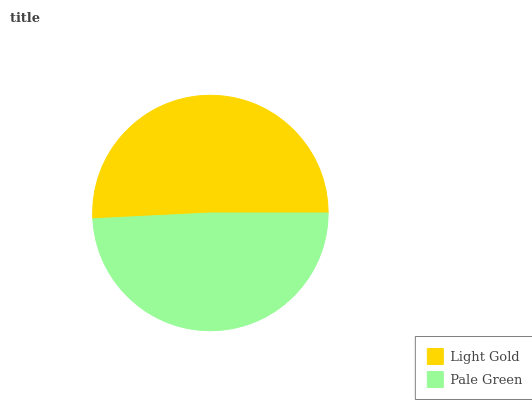Is Pale Green the minimum?
Answer yes or no. Yes. Is Light Gold the maximum?
Answer yes or no. Yes. Is Pale Green the maximum?
Answer yes or no. No. Is Light Gold greater than Pale Green?
Answer yes or no. Yes. Is Pale Green less than Light Gold?
Answer yes or no. Yes. Is Pale Green greater than Light Gold?
Answer yes or no. No. Is Light Gold less than Pale Green?
Answer yes or no. No. Is Light Gold the high median?
Answer yes or no. Yes. Is Pale Green the low median?
Answer yes or no. Yes. Is Pale Green the high median?
Answer yes or no. No. Is Light Gold the low median?
Answer yes or no. No. 